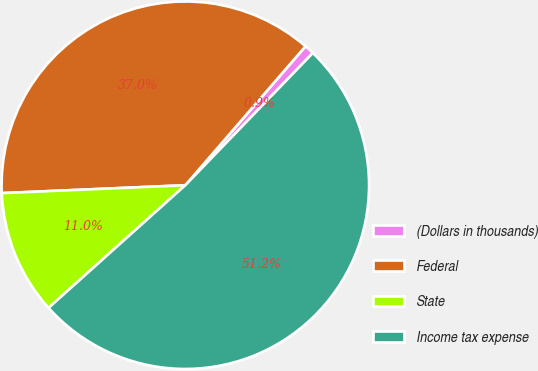<chart> <loc_0><loc_0><loc_500><loc_500><pie_chart><fcel>(Dollars in thousands)<fcel>Federal<fcel>State<fcel>Income tax expense<nl><fcel>0.86%<fcel>37.03%<fcel>10.95%<fcel>51.15%<nl></chart> 